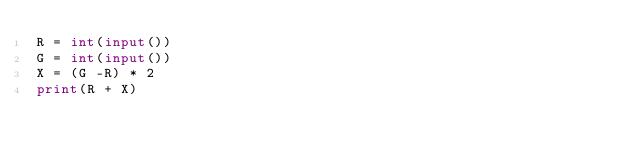<code> <loc_0><loc_0><loc_500><loc_500><_Python_>R = int(input())
G = int(input())
X = (G -R) * 2
print(R + X)</code> 